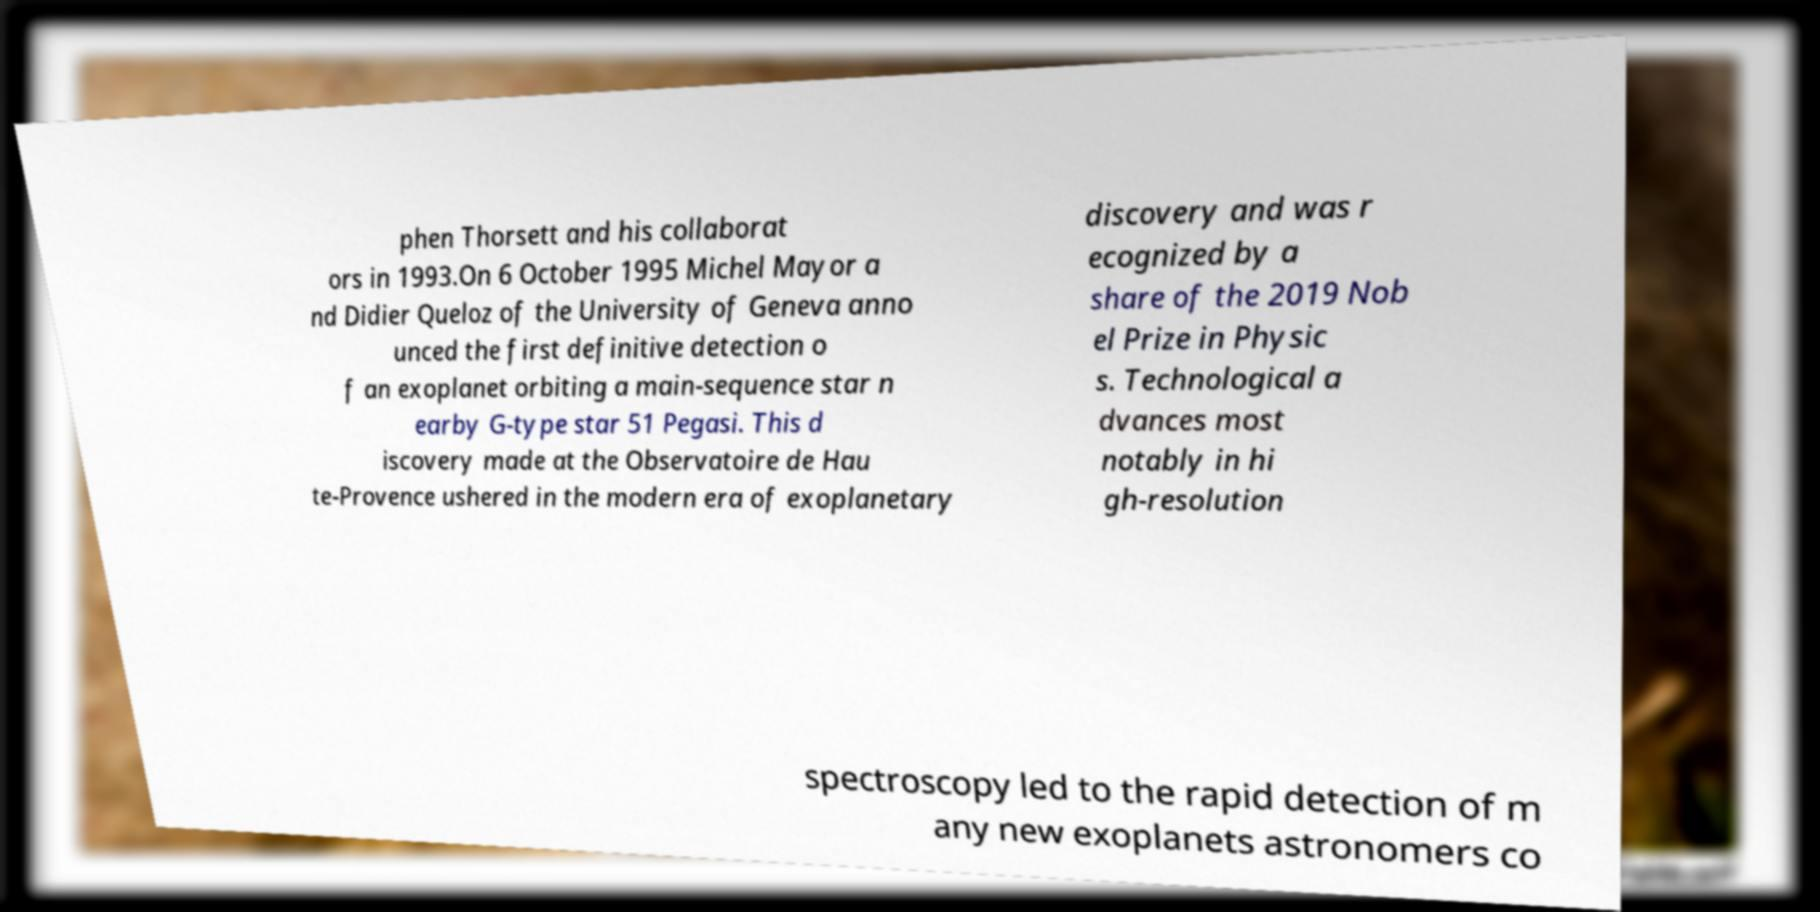Please identify and transcribe the text found in this image. phen Thorsett and his collaborat ors in 1993.On 6 October 1995 Michel Mayor a nd Didier Queloz of the University of Geneva anno unced the first definitive detection o f an exoplanet orbiting a main-sequence star n earby G-type star 51 Pegasi. This d iscovery made at the Observatoire de Hau te-Provence ushered in the modern era of exoplanetary discovery and was r ecognized by a share of the 2019 Nob el Prize in Physic s. Technological a dvances most notably in hi gh-resolution spectroscopy led to the rapid detection of m any new exoplanets astronomers co 